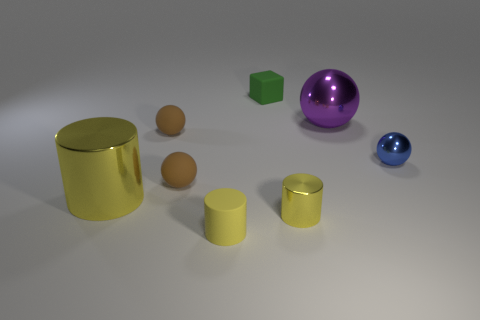There is a matte object that is the same color as the large cylinder; what is its shape?
Your response must be concise. Cylinder. There is a ball that is right of the small matte cube and in front of the big ball; what color is it?
Provide a succinct answer. Blue. Is there a thing that is behind the tiny metallic object behind the yellow object that is left of the yellow matte cylinder?
Your answer should be compact. Yes. What number of objects are tiny green rubber things or tiny purple cylinders?
Your response must be concise. 1. Is the material of the tiny green cube the same as the brown ball behind the tiny blue thing?
Make the answer very short. Yes. Is there any other thing of the same color as the small metallic cylinder?
Offer a very short reply. Yes. How many things are either tiny spheres that are on the right side of the tiny green object or tiny things that are behind the small blue thing?
Make the answer very short. 3. There is a metal object that is both to the left of the big purple shiny thing and to the right of the tiny block; what is its shape?
Your response must be concise. Cylinder. There is a object right of the purple sphere; what number of green rubber objects are in front of it?
Keep it short and to the point. 0. Is there anything else that has the same material as the big purple sphere?
Your answer should be compact. Yes. 